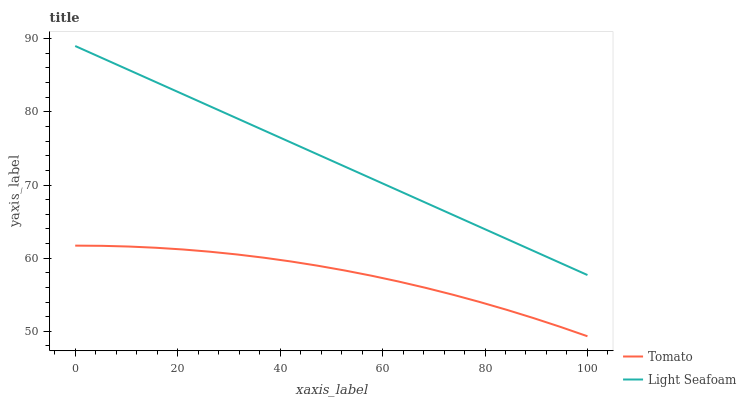Does Tomato have the minimum area under the curve?
Answer yes or no. Yes. Does Light Seafoam have the maximum area under the curve?
Answer yes or no. Yes. Does Light Seafoam have the minimum area under the curve?
Answer yes or no. No. Is Light Seafoam the smoothest?
Answer yes or no. Yes. Is Tomato the roughest?
Answer yes or no. Yes. Is Light Seafoam the roughest?
Answer yes or no. No. Does Light Seafoam have the lowest value?
Answer yes or no. No. Does Light Seafoam have the highest value?
Answer yes or no. Yes. Is Tomato less than Light Seafoam?
Answer yes or no. Yes. Is Light Seafoam greater than Tomato?
Answer yes or no. Yes. Does Tomato intersect Light Seafoam?
Answer yes or no. No. 